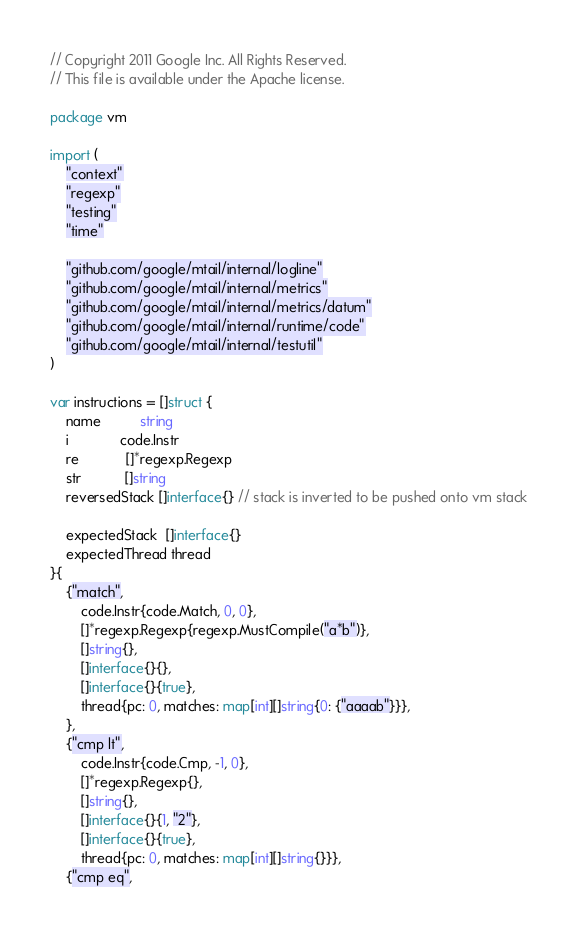Convert code to text. <code><loc_0><loc_0><loc_500><loc_500><_Go_>// Copyright 2011 Google Inc. All Rights Reserved.
// This file is available under the Apache license.

package vm

import (
	"context"
	"regexp"
	"testing"
	"time"

	"github.com/google/mtail/internal/logline"
	"github.com/google/mtail/internal/metrics"
	"github.com/google/mtail/internal/metrics/datum"
	"github.com/google/mtail/internal/runtime/code"
	"github.com/google/mtail/internal/testutil"
)

var instructions = []struct {
	name          string
	i             code.Instr
	re            []*regexp.Regexp
	str           []string
	reversedStack []interface{} // stack is inverted to be pushed onto vm stack

	expectedStack  []interface{}
	expectedThread thread
}{
	{"match",
		code.Instr{code.Match, 0, 0},
		[]*regexp.Regexp{regexp.MustCompile("a*b")},
		[]string{},
		[]interface{}{},
		[]interface{}{true},
		thread{pc: 0, matches: map[int][]string{0: {"aaaab"}}},
	},
	{"cmp lt",
		code.Instr{code.Cmp, -1, 0},
		[]*regexp.Regexp{},
		[]string{},
		[]interface{}{1, "2"},
		[]interface{}{true},
		thread{pc: 0, matches: map[int][]string{}}},
	{"cmp eq",</code> 